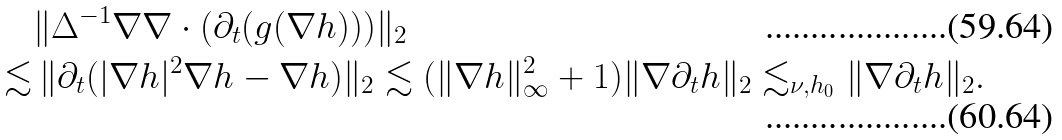Convert formula to latex. <formula><loc_0><loc_0><loc_500><loc_500>& \| \Delta ^ { - 1 } \nabla \nabla \cdot ( \partial _ { t } ( g ( \nabla h ) ) ) \| _ { 2 } \\ \lesssim & \, \| \partial _ { t } ( | \nabla h | ^ { 2 } \nabla h - \nabla h ) \| _ { 2 } \lesssim ( \| \nabla h \| _ { \infty } ^ { 2 } + 1 ) \| \nabla \partial _ { t } h \| _ { 2 } \lesssim _ { \nu , h _ { 0 } } \| \nabla \partial _ { t } h \| _ { 2 } .</formula> 